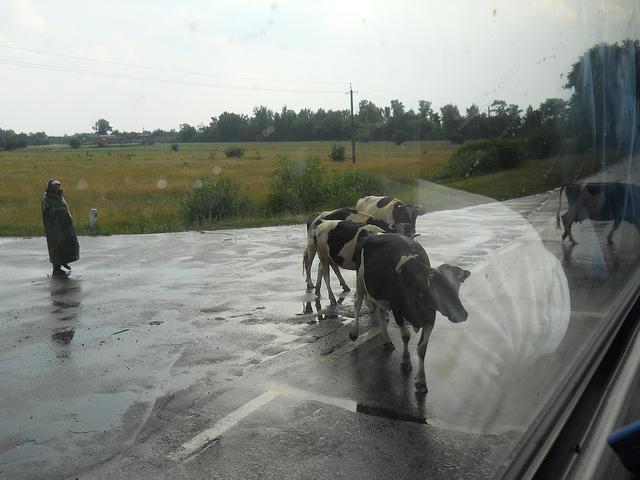How many cows are there?
Give a very brief answer. 4. How many cows are visible?
Give a very brief answer. 4. How many varieties of donuts are there?
Give a very brief answer. 0. 